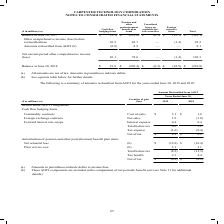According to Carpenter Technology's financial document, What do the amounts in parentheses in the table indicate? debits to income/loss.. The document states: "(a) Amounts in parentheses indicate debits to income/loss. (b) These AOCI components are included in the computation of net periodic benefit cost (see..." Also, Where are Net actuarial loss and Prior service cost included? in the computation of net periodic benefit cost (see Note 11 for additional details).. The document states: "ncome/loss. (b) These AOCI components are included in the computation of net periodic benefit cost (see Note 11 for additional details)...." Also, In which years is information on the amounts reclassified from AOCI provided? The document shows two values: 2019 and 2018. From the document: "($ in millions) (a) Location of gain (loss) 2019 2018 Details about AOCI Components Cash flow hedging items Commodity contracts Cost of sales $ 5.1 ($..." Additionally, In which year was the amount of tax benefit larger? According to the financial document, 2018. The relevant text states: "($ in millions) (a) Location of gain (loss) 2019 2018 Details about AOCI Components Cash flow hedging items Commodity contracts Cost of sales $ 5.1 $ 1.8..." Also, can you calculate: What was the change in Forward interest rate swaps in 2019 from 2018? I cannot find a specific answer to this question in the financial document. Also, can you calculate: What was the percentage change in Forward interest rate swaps in 2019 from 2018? I cannot find a specific answer to this question in the financial document. 